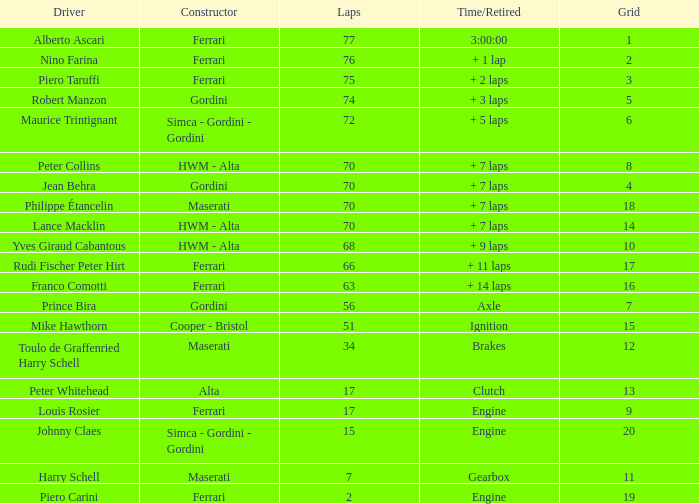How many grids for peter collins? 1.0. 